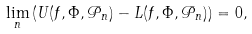<formula> <loc_0><loc_0><loc_500><loc_500>\lim _ { n } \left ( U ( f , \Phi , \mathcal { P } _ { n } ) - L ( f , \Phi , \mathcal { P } _ { n } ) \right ) = 0 ,</formula> 